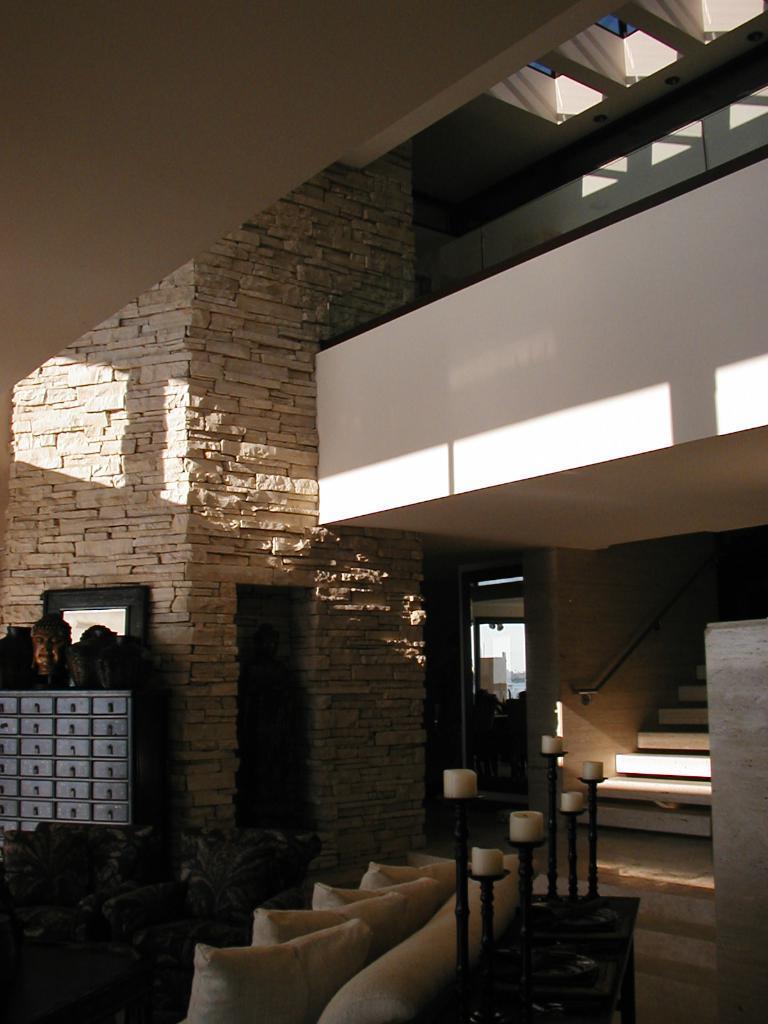Could you give a brief overview of what you see in this image? In this image we can see an inner view of a living room containing a sofa with some pillows, some candles placed on the table, stairs, some plants, a door and a cupboard. 